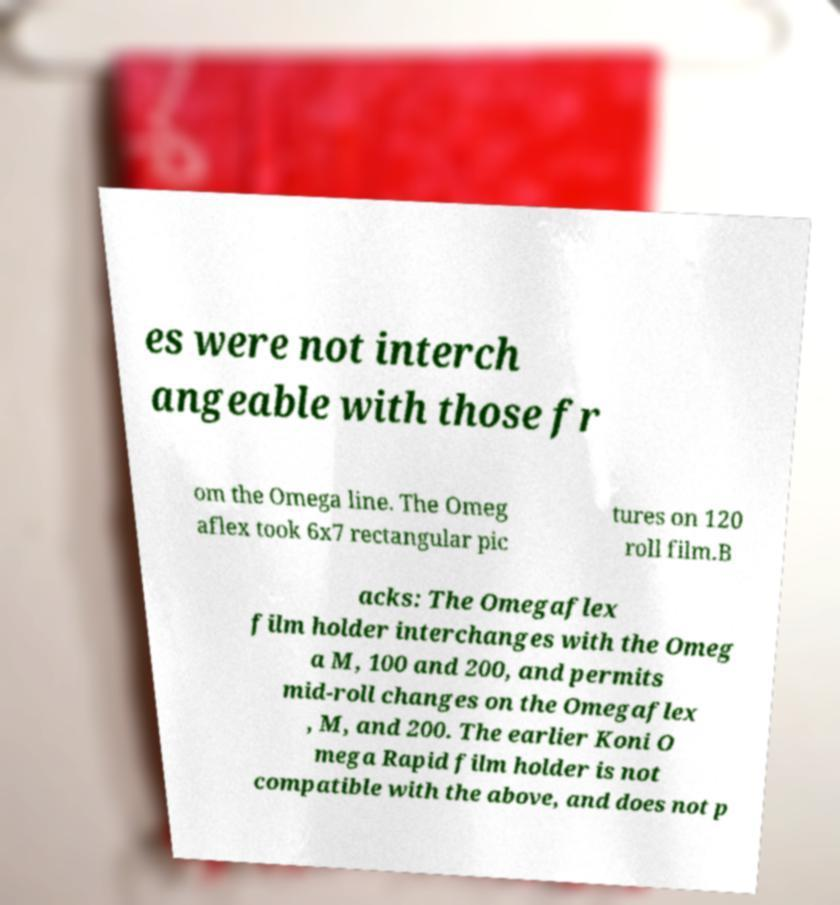I need the written content from this picture converted into text. Can you do that? es were not interch angeable with those fr om the Omega line. The Omeg aflex took 6x7 rectangular pic tures on 120 roll film.B acks: The Omegaflex film holder interchanges with the Omeg a M, 100 and 200, and permits mid-roll changes on the Omegaflex , M, and 200. The earlier Koni O mega Rapid film holder is not compatible with the above, and does not p 